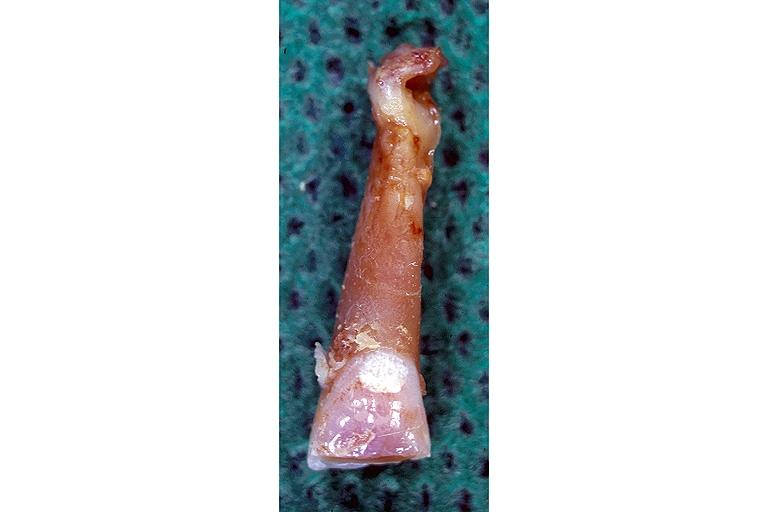what is present?
Answer the question using a single word or phrase. Oral 